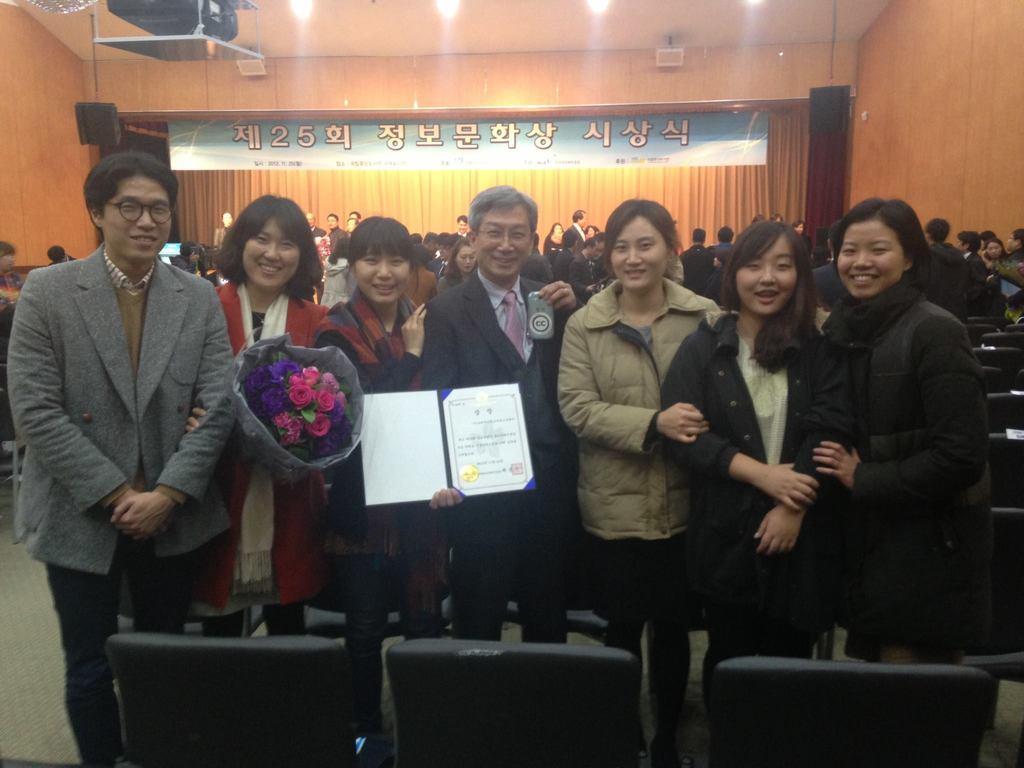Could you give a brief overview of what you see in this image? This is an inside view. Here I can see few people standing, smiling and giving pose for the picture. One person is holding a card and another person is holding a flower bouquet. At the back of these people there are many empty chairs. In the background, I can see a crowd of people standing. There is a banner on which I can see some text and also there is a curtain. At the top of the image there are lights attached to the ceiling and also there is a projector. 